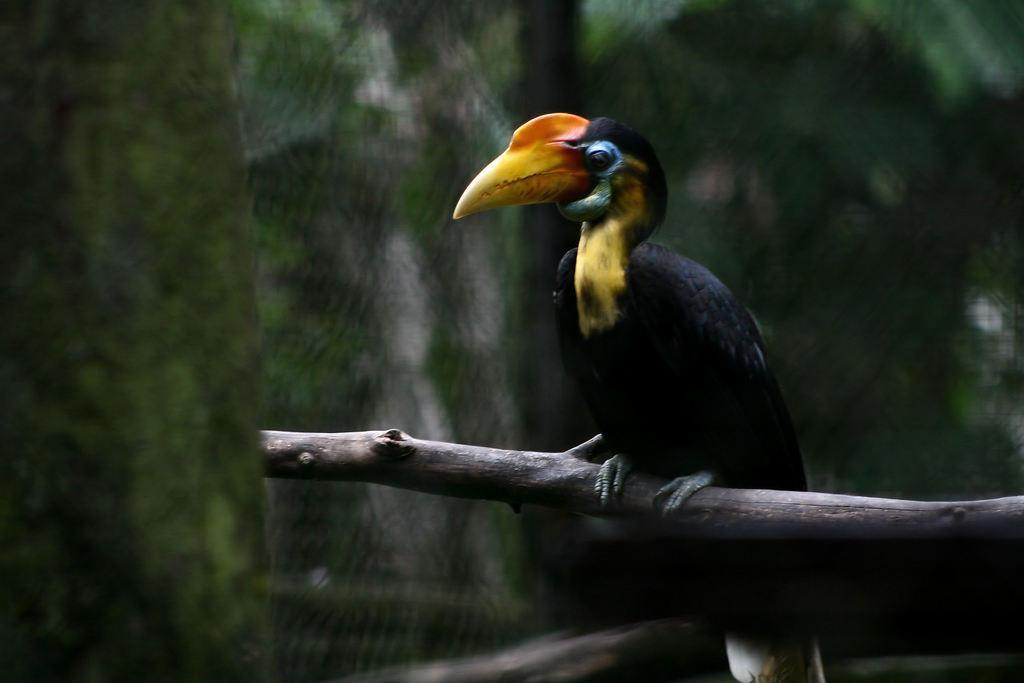Can you describe this image briefly? In the center of the image we can see a bird is present on the stick. In the background the image is blur. 